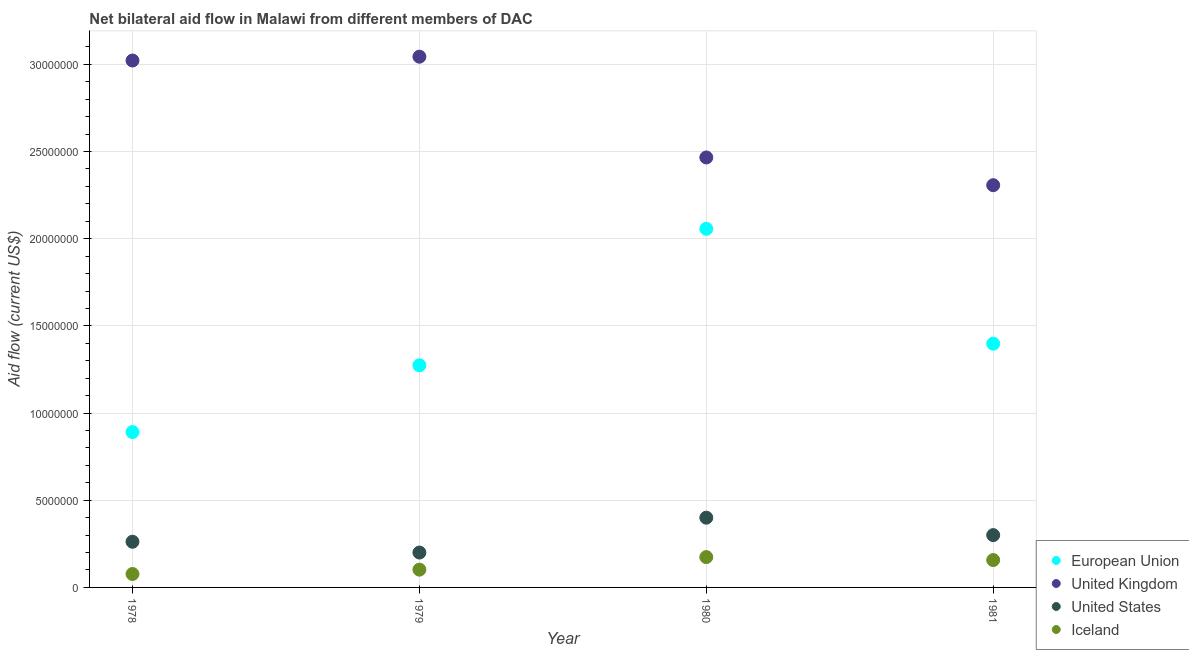What is the amount of aid given by iceland in 1980?
Ensure brevity in your answer.  1.74e+06. Across all years, what is the maximum amount of aid given by eu?
Your answer should be compact. 2.06e+07. Across all years, what is the minimum amount of aid given by us?
Make the answer very short. 2.00e+06. In which year was the amount of aid given by us maximum?
Offer a terse response. 1980. In which year was the amount of aid given by uk minimum?
Ensure brevity in your answer.  1981. What is the total amount of aid given by iceland in the graph?
Give a very brief answer. 5.10e+06. What is the difference between the amount of aid given by eu in 1978 and that in 1979?
Provide a short and direct response. -3.83e+06. What is the difference between the amount of aid given by uk in 1981 and the amount of aid given by eu in 1979?
Your answer should be very brief. 1.03e+07. What is the average amount of aid given by eu per year?
Your answer should be very brief. 1.40e+07. In the year 1978, what is the difference between the amount of aid given by uk and amount of aid given by iceland?
Offer a terse response. 2.94e+07. What is the ratio of the amount of aid given by us in 1978 to that in 1979?
Ensure brevity in your answer.  1.31. What is the difference between the highest and the second highest amount of aid given by us?
Give a very brief answer. 1.00e+06. What is the difference between the highest and the lowest amount of aid given by us?
Offer a terse response. 2.00e+06. Is the sum of the amount of aid given by uk in 1978 and 1981 greater than the maximum amount of aid given by eu across all years?
Keep it short and to the point. Yes. Is the amount of aid given by eu strictly greater than the amount of aid given by uk over the years?
Provide a succinct answer. No. What is the difference between two consecutive major ticks on the Y-axis?
Provide a short and direct response. 5.00e+06. Does the graph contain any zero values?
Your answer should be very brief. No. How many legend labels are there?
Offer a terse response. 4. How are the legend labels stacked?
Offer a very short reply. Vertical. What is the title of the graph?
Provide a short and direct response. Net bilateral aid flow in Malawi from different members of DAC. Does "PFC gas" appear as one of the legend labels in the graph?
Keep it short and to the point. No. What is the label or title of the Y-axis?
Keep it short and to the point. Aid flow (current US$). What is the Aid flow (current US$) in European Union in 1978?
Make the answer very short. 8.91e+06. What is the Aid flow (current US$) in United Kingdom in 1978?
Your answer should be compact. 3.02e+07. What is the Aid flow (current US$) in United States in 1978?
Offer a very short reply. 2.62e+06. What is the Aid flow (current US$) of Iceland in 1978?
Offer a terse response. 7.70e+05. What is the Aid flow (current US$) of European Union in 1979?
Your answer should be very brief. 1.27e+07. What is the Aid flow (current US$) in United Kingdom in 1979?
Keep it short and to the point. 3.04e+07. What is the Aid flow (current US$) of United States in 1979?
Your answer should be very brief. 2.00e+06. What is the Aid flow (current US$) in Iceland in 1979?
Keep it short and to the point. 1.02e+06. What is the Aid flow (current US$) in European Union in 1980?
Provide a succinct answer. 2.06e+07. What is the Aid flow (current US$) in United Kingdom in 1980?
Your response must be concise. 2.47e+07. What is the Aid flow (current US$) in United States in 1980?
Give a very brief answer. 4.00e+06. What is the Aid flow (current US$) of Iceland in 1980?
Make the answer very short. 1.74e+06. What is the Aid flow (current US$) of European Union in 1981?
Your answer should be compact. 1.40e+07. What is the Aid flow (current US$) of United Kingdom in 1981?
Ensure brevity in your answer.  2.31e+07. What is the Aid flow (current US$) in Iceland in 1981?
Offer a terse response. 1.57e+06. Across all years, what is the maximum Aid flow (current US$) of European Union?
Make the answer very short. 2.06e+07. Across all years, what is the maximum Aid flow (current US$) in United Kingdom?
Your response must be concise. 3.04e+07. Across all years, what is the maximum Aid flow (current US$) in United States?
Your answer should be compact. 4.00e+06. Across all years, what is the maximum Aid flow (current US$) of Iceland?
Make the answer very short. 1.74e+06. Across all years, what is the minimum Aid flow (current US$) of European Union?
Provide a succinct answer. 8.91e+06. Across all years, what is the minimum Aid flow (current US$) of United Kingdom?
Offer a very short reply. 2.31e+07. Across all years, what is the minimum Aid flow (current US$) of Iceland?
Your answer should be compact. 7.70e+05. What is the total Aid flow (current US$) of European Union in the graph?
Your response must be concise. 5.62e+07. What is the total Aid flow (current US$) in United Kingdom in the graph?
Keep it short and to the point. 1.08e+08. What is the total Aid flow (current US$) of United States in the graph?
Keep it short and to the point. 1.16e+07. What is the total Aid flow (current US$) in Iceland in the graph?
Offer a very short reply. 5.10e+06. What is the difference between the Aid flow (current US$) in European Union in 1978 and that in 1979?
Ensure brevity in your answer.  -3.83e+06. What is the difference between the Aid flow (current US$) in United States in 1978 and that in 1979?
Your answer should be compact. 6.20e+05. What is the difference between the Aid flow (current US$) of Iceland in 1978 and that in 1979?
Make the answer very short. -2.50e+05. What is the difference between the Aid flow (current US$) in European Union in 1978 and that in 1980?
Provide a short and direct response. -1.17e+07. What is the difference between the Aid flow (current US$) of United Kingdom in 1978 and that in 1980?
Ensure brevity in your answer.  5.56e+06. What is the difference between the Aid flow (current US$) in United States in 1978 and that in 1980?
Keep it short and to the point. -1.38e+06. What is the difference between the Aid flow (current US$) in Iceland in 1978 and that in 1980?
Ensure brevity in your answer.  -9.70e+05. What is the difference between the Aid flow (current US$) in European Union in 1978 and that in 1981?
Ensure brevity in your answer.  -5.07e+06. What is the difference between the Aid flow (current US$) of United Kingdom in 1978 and that in 1981?
Your answer should be compact. 7.15e+06. What is the difference between the Aid flow (current US$) of United States in 1978 and that in 1981?
Make the answer very short. -3.80e+05. What is the difference between the Aid flow (current US$) in Iceland in 1978 and that in 1981?
Your answer should be compact. -8.00e+05. What is the difference between the Aid flow (current US$) of European Union in 1979 and that in 1980?
Keep it short and to the point. -7.83e+06. What is the difference between the Aid flow (current US$) of United Kingdom in 1979 and that in 1980?
Keep it short and to the point. 5.78e+06. What is the difference between the Aid flow (current US$) of Iceland in 1979 and that in 1980?
Your response must be concise. -7.20e+05. What is the difference between the Aid flow (current US$) in European Union in 1979 and that in 1981?
Keep it short and to the point. -1.24e+06. What is the difference between the Aid flow (current US$) in United Kingdom in 1979 and that in 1981?
Your answer should be very brief. 7.37e+06. What is the difference between the Aid flow (current US$) of Iceland in 1979 and that in 1981?
Provide a short and direct response. -5.50e+05. What is the difference between the Aid flow (current US$) in European Union in 1980 and that in 1981?
Your answer should be compact. 6.59e+06. What is the difference between the Aid flow (current US$) in United Kingdom in 1980 and that in 1981?
Give a very brief answer. 1.59e+06. What is the difference between the Aid flow (current US$) of European Union in 1978 and the Aid flow (current US$) of United Kingdom in 1979?
Provide a succinct answer. -2.15e+07. What is the difference between the Aid flow (current US$) in European Union in 1978 and the Aid flow (current US$) in United States in 1979?
Offer a terse response. 6.91e+06. What is the difference between the Aid flow (current US$) of European Union in 1978 and the Aid flow (current US$) of Iceland in 1979?
Your answer should be very brief. 7.89e+06. What is the difference between the Aid flow (current US$) of United Kingdom in 1978 and the Aid flow (current US$) of United States in 1979?
Provide a succinct answer. 2.82e+07. What is the difference between the Aid flow (current US$) of United Kingdom in 1978 and the Aid flow (current US$) of Iceland in 1979?
Ensure brevity in your answer.  2.92e+07. What is the difference between the Aid flow (current US$) of United States in 1978 and the Aid flow (current US$) of Iceland in 1979?
Offer a very short reply. 1.60e+06. What is the difference between the Aid flow (current US$) of European Union in 1978 and the Aid flow (current US$) of United Kingdom in 1980?
Offer a terse response. -1.58e+07. What is the difference between the Aid flow (current US$) in European Union in 1978 and the Aid flow (current US$) in United States in 1980?
Your answer should be very brief. 4.91e+06. What is the difference between the Aid flow (current US$) in European Union in 1978 and the Aid flow (current US$) in Iceland in 1980?
Make the answer very short. 7.17e+06. What is the difference between the Aid flow (current US$) of United Kingdom in 1978 and the Aid flow (current US$) of United States in 1980?
Your answer should be very brief. 2.62e+07. What is the difference between the Aid flow (current US$) in United Kingdom in 1978 and the Aid flow (current US$) in Iceland in 1980?
Your response must be concise. 2.85e+07. What is the difference between the Aid flow (current US$) of United States in 1978 and the Aid flow (current US$) of Iceland in 1980?
Offer a terse response. 8.80e+05. What is the difference between the Aid flow (current US$) of European Union in 1978 and the Aid flow (current US$) of United Kingdom in 1981?
Your answer should be very brief. -1.42e+07. What is the difference between the Aid flow (current US$) in European Union in 1978 and the Aid flow (current US$) in United States in 1981?
Ensure brevity in your answer.  5.91e+06. What is the difference between the Aid flow (current US$) of European Union in 1978 and the Aid flow (current US$) of Iceland in 1981?
Your response must be concise. 7.34e+06. What is the difference between the Aid flow (current US$) of United Kingdom in 1978 and the Aid flow (current US$) of United States in 1981?
Give a very brief answer. 2.72e+07. What is the difference between the Aid flow (current US$) in United Kingdom in 1978 and the Aid flow (current US$) in Iceland in 1981?
Keep it short and to the point. 2.86e+07. What is the difference between the Aid flow (current US$) in United States in 1978 and the Aid flow (current US$) in Iceland in 1981?
Provide a short and direct response. 1.05e+06. What is the difference between the Aid flow (current US$) of European Union in 1979 and the Aid flow (current US$) of United Kingdom in 1980?
Offer a very short reply. -1.19e+07. What is the difference between the Aid flow (current US$) of European Union in 1979 and the Aid flow (current US$) of United States in 1980?
Make the answer very short. 8.74e+06. What is the difference between the Aid flow (current US$) in European Union in 1979 and the Aid flow (current US$) in Iceland in 1980?
Provide a succinct answer. 1.10e+07. What is the difference between the Aid flow (current US$) of United Kingdom in 1979 and the Aid flow (current US$) of United States in 1980?
Your answer should be very brief. 2.64e+07. What is the difference between the Aid flow (current US$) in United Kingdom in 1979 and the Aid flow (current US$) in Iceland in 1980?
Your answer should be compact. 2.87e+07. What is the difference between the Aid flow (current US$) in United States in 1979 and the Aid flow (current US$) in Iceland in 1980?
Your response must be concise. 2.60e+05. What is the difference between the Aid flow (current US$) in European Union in 1979 and the Aid flow (current US$) in United Kingdom in 1981?
Offer a very short reply. -1.03e+07. What is the difference between the Aid flow (current US$) of European Union in 1979 and the Aid flow (current US$) of United States in 1981?
Provide a succinct answer. 9.74e+06. What is the difference between the Aid flow (current US$) in European Union in 1979 and the Aid flow (current US$) in Iceland in 1981?
Your answer should be very brief. 1.12e+07. What is the difference between the Aid flow (current US$) in United Kingdom in 1979 and the Aid flow (current US$) in United States in 1981?
Your response must be concise. 2.74e+07. What is the difference between the Aid flow (current US$) of United Kingdom in 1979 and the Aid flow (current US$) of Iceland in 1981?
Offer a very short reply. 2.89e+07. What is the difference between the Aid flow (current US$) in European Union in 1980 and the Aid flow (current US$) in United Kingdom in 1981?
Offer a terse response. -2.50e+06. What is the difference between the Aid flow (current US$) of European Union in 1980 and the Aid flow (current US$) of United States in 1981?
Your answer should be very brief. 1.76e+07. What is the difference between the Aid flow (current US$) of European Union in 1980 and the Aid flow (current US$) of Iceland in 1981?
Your answer should be very brief. 1.90e+07. What is the difference between the Aid flow (current US$) in United Kingdom in 1980 and the Aid flow (current US$) in United States in 1981?
Provide a short and direct response. 2.17e+07. What is the difference between the Aid flow (current US$) in United Kingdom in 1980 and the Aid flow (current US$) in Iceland in 1981?
Keep it short and to the point. 2.31e+07. What is the difference between the Aid flow (current US$) of United States in 1980 and the Aid flow (current US$) of Iceland in 1981?
Offer a very short reply. 2.43e+06. What is the average Aid flow (current US$) in European Union per year?
Provide a succinct answer. 1.40e+07. What is the average Aid flow (current US$) of United Kingdom per year?
Ensure brevity in your answer.  2.71e+07. What is the average Aid flow (current US$) in United States per year?
Keep it short and to the point. 2.90e+06. What is the average Aid flow (current US$) of Iceland per year?
Make the answer very short. 1.28e+06. In the year 1978, what is the difference between the Aid flow (current US$) of European Union and Aid flow (current US$) of United Kingdom?
Provide a succinct answer. -2.13e+07. In the year 1978, what is the difference between the Aid flow (current US$) of European Union and Aid flow (current US$) of United States?
Your answer should be compact. 6.29e+06. In the year 1978, what is the difference between the Aid flow (current US$) of European Union and Aid flow (current US$) of Iceland?
Provide a short and direct response. 8.14e+06. In the year 1978, what is the difference between the Aid flow (current US$) of United Kingdom and Aid flow (current US$) of United States?
Make the answer very short. 2.76e+07. In the year 1978, what is the difference between the Aid flow (current US$) of United Kingdom and Aid flow (current US$) of Iceland?
Ensure brevity in your answer.  2.94e+07. In the year 1978, what is the difference between the Aid flow (current US$) in United States and Aid flow (current US$) in Iceland?
Keep it short and to the point. 1.85e+06. In the year 1979, what is the difference between the Aid flow (current US$) of European Union and Aid flow (current US$) of United Kingdom?
Offer a very short reply. -1.77e+07. In the year 1979, what is the difference between the Aid flow (current US$) of European Union and Aid flow (current US$) of United States?
Keep it short and to the point. 1.07e+07. In the year 1979, what is the difference between the Aid flow (current US$) in European Union and Aid flow (current US$) in Iceland?
Make the answer very short. 1.17e+07. In the year 1979, what is the difference between the Aid flow (current US$) in United Kingdom and Aid flow (current US$) in United States?
Provide a short and direct response. 2.84e+07. In the year 1979, what is the difference between the Aid flow (current US$) in United Kingdom and Aid flow (current US$) in Iceland?
Provide a succinct answer. 2.94e+07. In the year 1979, what is the difference between the Aid flow (current US$) in United States and Aid flow (current US$) in Iceland?
Provide a short and direct response. 9.80e+05. In the year 1980, what is the difference between the Aid flow (current US$) in European Union and Aid flow (current US$) in United Kingdom?
Keep it short and to the point. -4.09e+06. In the year 1980, what is the difference between the Aid flow (current US$) of European Union and Aid flow (current US$) of United States?
Ensure brevity in your answer.  1.66e+07. In the year 1980, what is the difference between the Aid flow (current US$) of European Union and Aid flow (current US$) of Iceland?
Make the answer very short. 1.88e+07. In the year 1980, what is the difference between the Aid flow (current US$) in United Kingdom and Aid flow (current US$) in United States?
Your answer should be compact. 2.07e+07. In the year 1980, what is the difference between the Aid flow (current US$) in United Kingdom and Aid flow (current US$) in Iceland?
Make the answer very short. 2.29e+07. In the year 1980, what is the difference between the Aid flow (current US$) in United States and Aid flow (current US$) in Iceland?
Ensure brevity in your answer.  2.26e+06. In the year 1981, what is the difference between the Aid flow (current US$) of European Union and Aid flow (current US$) of United Kingdom?
Your answer should be very brief. -9.09e+06. In the year 1981, what is the difference between the Aid flow (current US$) of European Union and Aid flow (current US$) of United States?
Keep it short and to the point. 1.10e+07. In the year 1981, what is the difference between the Aid flow (current US$) in European Union and Aid flow (current US$) in Iceland?
Offer a terse response. 1.24e+07. In the year 1981, what is the difference between the Aid flow (current US$) in United Kingdom and Aid flow (current US$) in United States?
Offer a terse response. 2.01e+07. In the year 1981, what is the difference between the Aid flow (current US$) in United Kingdom and Aid flow (current US$) in Iceland?
Offer a terse response. 2.15e+07. In the year 1981, what is the difference between the Aid flow (current US$) of United States and Aid flow (current US$) of Iceland?
Keep it short and to the point. 1.43e+06. What is the ratio of the Aid flow (current US$) of European Union in 1978 to that in 1979?
Make the answer very short. 0.7. What is the ratio of the Aid flow (current US$) in United Kingdom in 1978 to that in 1979?
Provide a short and direct response. 0.99. What is the ratio of the Aid flow (current US$) in United States in 1978 to that in 1979?
Make the answer very short. 1.31. What is the ratio of the Aid flow (current US$) of Iceland in 1978 to that in 1979?
Provide a succinct answer. 0.75. What is the ratio of the Aid flow (current US$) in European Union in 1978 to that in 1980?
Offer a very short reply. 0.43. What is the ratio of the Aid flow (current US$) of United Kingdom in 1978 to that in 1980?
Your answer should be compact. 1.23. What is the ratio of the Aid flow (current US$) in United States in 1978 to that in 1980?
Make the answer very short. 0.66. What is the ratio of the Aid flow (current US$) of Iceland in 1978 to that in 1980?
Offer a terse response. 0.44. What is the ratio of the Aid flow (current US$) of European Union in 1978 to that in 1981?
Give a very brief answer. 0.64. What is the ratio of the Aid flow (current US$) of United Kingdom in 1978 to that in 1981?
Provide a succinct answer. 1.31. What is the ratio of the Aid flow (current US$) of United States in 1978 to that in 1981?
Ensure brevity in your answer.  0.87. What is the ratio of the Aid flow (current US$) of Iceland in 1978 to that in 1981?
Offer a terse response. 0.49. What is the ratio of the Aid flow (current US$) in European Union in 1979 to that in 1980?
Offer a terse response. 0.62. What is the ratio of the Aid flow (current US$) in United Kingdom in 1979 to that in 1980?
Ensure brevity in your answer.  1.23. What is the ratio of the Aid flow (current US$) of Iceland in 1979 to that in 1980?
Give a very brief answer. 0.59. What is the ratio of the Aid flow (current US$) of European Union in 1979 to that in 1981?
Give a very brief answer. 0.91. What is the ratio of the Aid flow (current US$) in United Kingdom in 1979 to that in 1981?
Your answer should be very brief. 1.32. What is the ratio of the Aid flow (current US$) of Iceland in 1979 to that in 1981?
Give a very brief answer. 0.65. What is the ratio of the Aid flow (current US$) of European Union in 1980 to that in 1981?
Offer a very short reply. 1.47. What is the ratio of the Aid flow (current US$) of United Kingdom in 1980 to that in 1981?
Your answer should be very brief. 1.07. What is the ratio of the Aid flow (current US$) in United States in 1980 to that in 1981?
Offer a terse response. 1.33. What is the ratio of the Aid flow (current US$) of Iceland in 1980 to that in 1981?
Your response must be concise. 1.11. What is the difference between the highest and the second highest Aid flow (current US$) in European Union?
Keep it short and to the point. 6.59e+06. What is the difference between the highest and the second highest Aid flow (current US$) in United Kingdom?
Provide a succinct answer. 2.20e+05. What is the difference between the highest and the second highest Aid flow (current US$) in United States?
Keep it short and to the point. 1.00e+06. What is the difference between the highest and the lowest Aid flow (current US$) in European Union?
Offer a terse response. 1.17e+07. What is the difference between the highest and the lowest Aid flow (current US$) in United Kingdom?
Provide a short and direct response. 7.37e+06. What is the difference between the highest and the lowest Aid flow (current US$) of United States?
Your response must be concise. 2.00e+06. What is the difference between the highest and the lowest Aid flow (current US$) in Iceland?
Keep it short and to the point. 9.70e+05. 